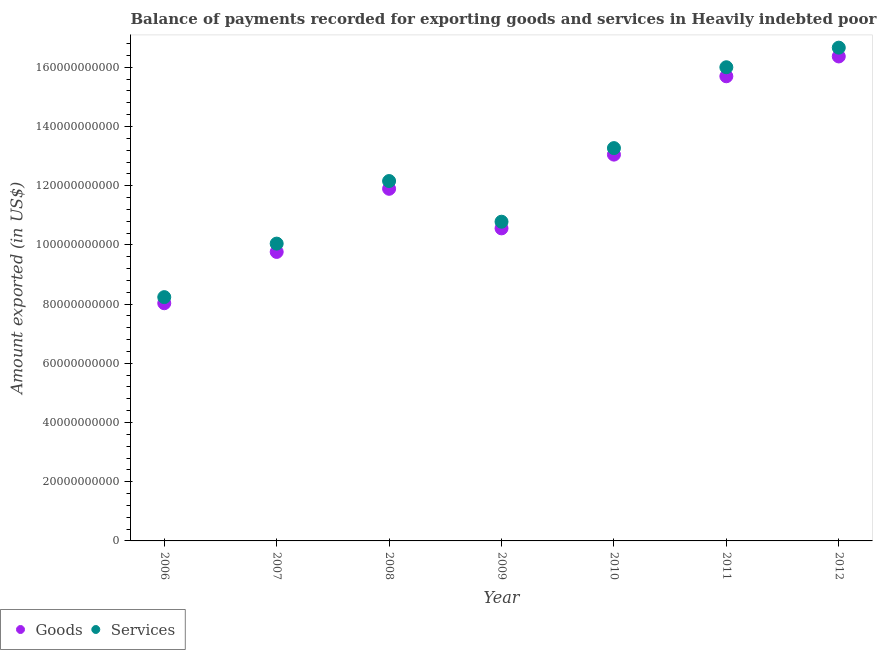How many different coloured dotlines are there?
Make the answer very short. 2. What is the amount of services exported in 2006?
Your answer should be very brief. 8.24e+1. Across all years, what is the maximum amount of goods exported?
Give a very brief answer. 1.64e+11. Across all years, what is the minimum amount of goods exported?
Offer a terse response. 8.03e+1. In which year was the amount of goods exported minimum?
Offer a terse response. 2006. What is the total amount of goods exported in the graph?
Provide a short and direct response. 8.54e+11. What is the difference between the amount of services exported in 2010 and that in 2011?
Keep it short and to the point. -2.73e+1. What is the difference between the amount of goods exported in 2007 and the amount of services exported in 2010?
Ensure brevity in your answer.  -3.51e+1. What is the average amount of services exported per year?
Give a very brief answer. 1.25e+11. In the year 2008, what is the difference between the amount of services exported and amount of goods exported?
Make the answer very short. 2.62e+09. What is the ratio of the amount of goods exported in 2011 to that in 2012?
Give a very brief answer. 0.96. Is the difference between the amount of services exported in 2010 and 2011 greater than the difference between the amount of goods exported in 2010 and 2011?
Offer a very short reply. No. What is the difference between the highest and the second highest amount of services exported?
Your answer should be compact. 6.62e+09. What is the difference between the highest and the lowest amount of goods exported?
Provide a short and direct response. 8.34e+1. Is the amount of goods exported strictly greater than the amount of services exported over the years?
Provide a short and direct response. No. How many dotlines are there?
Provide a succinct answer. 2. How many years are there in the graph?
Offer a terse response. 7. Does the graph contain any zero values?
Keep it short and to the point. No. Does the graph contain grids?
Offer a terse response. No. What is the title of the graph?
Provide a short and direct response. Balance of payments recorded for exporting goods and services in Heavily indebted poor countries. Does "Male entrants" appear as one of the legend labels in the graph?
Make the answer very short. No. What is the label or title of the X-axis?
Your answer should be compact. Year. What is the label or title of the Y-axis?
Your response must be concise. Amount exported (in US$). What is the Amount exported (in US$) in Goods in 2006?
Provide a short and direct response. 8.03e+1. What is the Amount exported (in US$) of Services in 2006?
Make the answer very short. 8.24e+1. What is the Amount exported (in US$) in Goods in 2007?
Your response must be concise. 9.76e+1. What is the Amount exported (in US$) in Services in 2007?
Make the answer very short. 1.00e+11. What is the Amount exported (in US$) in Goods in 2008?
Provide a succinct answer. 1.19e+11. What is the Amount exported (in US$) in Services in 2008?
Ensure brevity in your answer.  1.22e+11. What is the Amount exported (in US$) in Goods in 2009?
Your answer should be compact. 1.06e+11. What is the Amount exported (in US$) in Services in 2009?
Make the answer very short. 1.08e+11. What is the Amount exported (in US$) of Goods in 2010?
Provide a succinct answer. 1.30e+11. What is the Amount exported (in US$) in Services in 2010?
Your answer should be very brief. 1.33e+11. What is the Amount exported (in US$) in Goods in 2011?
Your answer should be very brief. 1.57e+11. What is the Amount exported (in US$) in Services in 2011?
Offer a terse response. 1.60e+11. What is the Amount exported (in US$) of Goods in 2012?
Offer a very short reply. 1.64e+11. What is the Amount exported (in US$) of Services in 2012?
Ensure brevity in your answer.  1.67e+11. Across all years, what is the maximum Amount exported (in US$) in Goods?
Keep it short and to the point. 1.64e+11. Across all years, what is the maximum Amount exported (in US$) in Services?
Provide a short and direct response. 1.67e+11. Across all years, what is the minimum Amount exported (in US$) in Goods?
Offer a very short reply. 8.03e+1. Across all years, what is the minimum Amount exported (in US$) of Services?
Give a very brief answer. 8.24e+1. What is the total Amount exported (in US$) of Goods in the graph?
Provide a short and direct response. 8.54e+11. What is the total Amount exported (in US$) in Services in the graph?
Your answer should be compact. 8.72e+11. What is the difference between the Amount exported (in US$) in Goods in 2006 and that in 2007?
Offer a terse response. -1.73e+1. What is the difference between the Amount exported (in US$) in Services in 2006 and that in 2007?
Your answer should be compact. -1.81e+1. What is the difference between the Amount exported (in US$) of Goods in 2006 and that in 2008?
Give a very brief answer. -3.87e+1. What is the difference between the Amount exported (in US$) in Services in 2006 and that in 2008?
Ensure brevity in your answer.  -3.92e+1. What is the difference between the Amount exported (in US$) in Goods in 2006 and that in 2009?
Give a very brief answer. -2.53e+1. What is the difference between the Amount exported (in US$) of Services in 2006 and that in 2009?
Ensure brevity in your answer.  -2.55e+1. What is the difference between the Amount exported (in US$) in Goods in 2006 and that in 2010?
Your answer should be very brief. -5.02e+1. What is the difference between the Amount exported (in US$) in Services in 2006 and that in 2010?
Give a very brief answer. -5.03e+1. What is the difference between the Amount exported (in US$) in Goods in 2006 and that in 2011?
Provide a succinct answer. -7.67e+1. What is the difference between the Amount exported (in US$) of Services in 2006 and that in 2011?
Keep it short and to the point. -7.77e+1. What is the difference between the Amount exported (in US$) of Goods in 2006 and that in 2012?
Offer a terse response. -8.34e+1. What is the difference between the Amount exported (in US$) in Services in 2006 and that in 2012?
Give a very brief answer. -8.43e+1. What is the difference between the Amount exported (in US$) in Goods in 2007 and that in 2008?
Provide a succinct answer. -2.13e+1. What is the difference between the Amount exported (in US$) of Services in 2007 and that in 2008?
Your answer should be very brief. -2.11e+1. What is the difference between the Amount exported (in US$) of Goods in 2007 and that in 2009?
Your answer should be very brief. -7.96e+09. What is the difference between the Amount exported (in US$) of Services in 2007 and that in 2009?
Offer a very short reply. -7.40e+09. What is the difference between the Amount exported (in US$) of Goods in 2007 and that in 2010?
Provide a succinct answer. -3.29e+1. What is the difference between the Amount exported (in US$) of Services in 2007 and that in 2010?
Offer a terse response. -3.23e+1. What is the difference between the Amount exported (in US$) in Goods in 2007 and that in 2011?
Provide a short and direct response. -5.93e+1. What is the difference between the Amount exported (in US$) of Services in 2007 and that in 2011?
Provide a short and direct response. -5.96e+1. What is the difference between the Amount exported (in US$) in Goods in 2007 and that in 2012?
Your response must be concise. -6.60e+1. What is the difference between the Amount exported (in US$) of Services in 2007 and that in 2012?
Offer a very short reply. -6.62e+1. What is the difference between the Amount exported (in US$) in Goods in 2008 and that in 2009?
Offer a very short reply. 1.34e+1. What is the difference between the Amount exported (in US$) of Services in 2008 and that in 2009?
Offer a terse response. 1.37e+1. What is the difference between the Amount exported (in US$) in Goods in 2008 and that in 2010?
Give a very brief answer. -1.15e+1. What is the difference between the Amount exported (in US$) in Services in 2008 and that in 2010?
Your response must be concise. -1.11e+1. What is the difference between the Amount exported (in US$) in Goods in 2008 and that in 2011?
Make the answer very short. -3.80e+1. What is the difference between the Amount exported (in US$) of Services in 2008 and that in 2011?
Your response must be concise. -3.84e+1. What is the difference between the Amount exported (in US$) in Goods in 2008 and that in 2012?
Give a very brief answer. -4.47e+1. What is the difference between the Amount exported (in US$) of Services in 2008 and that in 2012?
Provide a short and direct response. -4.51e+1. What is the difference between the Amount exported (in US$) of Goods in 2009 and that in 2010?
Keep it short and to the point. -2.49e+1. What is the difference between the Amount exported (in US$) of Services in 2009 and that in 2010?
Offer a very short reply. -2.49e+1. What is the difference between the Amount exported (in US$) of Goods in 2009 and that in 2011?
Keep it short and to the point. -5.14e+1. What is the difference between the Amount exported (in US$) in Services in 2009 and that in 2011?
Ensure brevity in your answer.  -5.22e+1. What is the difference between the Amount exported (in US$) of Goods in 2009 and that in 2012?
Make the answer very short. -5.81e+1. What is the difference between the Amount exported (in US$) of Services in 2009 and that in 2012?
Give a very brief answer. -5.88e+1. What is the difference between the Amount exported (in US$) of Goods in 2010 and that in 2011?
Make the answer very short. -2.65e+1. What is the difference between the Amount exported (in US$) of Services in 2010 and that in 2011?
Keep it short and to the point. -2.73e+1. What is the difference between the Amount exported (in US$) in Goods in 2010 and that in 2012?
Your answer should be very brief. -3.32e+1. What is the difference between the Amount exported (in US$) of Services in 2010 and that in 2012?
Provide a succinct answer. -3.39e+1. What is the difference between the Amount exported (in US$) of Goods in 2011 and that in 2012?
Your answer should be compact. -6.70e+09. What is the difference between the Amount exported (in US$) of Services in 2011 and that in 2012?
Give a very brief answer. -6.62e+09. What is the difference between the Amount exported (in US$) of Goods in 2006 and the Amount exported (in US$) of Services in 2007?
Keep it short and to the point. -2.01e+1. What is the difference between the Amount exported (in US$) in Goods in 2006 and the Amount exported (in US$) in Services in 2008?
Keep it short and to the point. -4.13e+1. What is the difference between the Amount exported (in US$) of Goods in 2006 and the Amount exported (in US$) of Services in 2009?
Ensure brevity in your answer.  -2.75e+1. What is the difference between the Amount exported (in US$) in Goods in 2006 and the Amount exported (in US$) in Services in 2010?
Keep it short and to the point. -5.24e+1. What is the difference between the Amount exported (in US$) of Goods in 2006 and the Amount exported (in US$) of Services in 2011?
Give a very brief answer. -7.97e+1. What is the difference between the Amount exported (in US$) in Goods in 2006 and the Amount exported (in US$) in Services in 2012?
Make the answer very short. -8.63e+1. What is the difference between the Amount exported (in US$) in Goods in 2007 and the Amount exported (in US$) in Services in 2008?
Make the answer very short. -2.39e+1. What is the difference between the Amount exported (in US$) in Goods in 2007 and the Amount exported (in US$) in Services in 2009?
Make the answer very short. -1.02e+1. What is the difference between the Amount exported (in US$) of Goods in 2007 and the Amount exported (in US$) of Services in 2010?
Your response must be concise. -3.51e+1. What is the difference between the Amount exported (in US$) in Goods in 2007 and the Amount exported (in US$) in Services in 2011?
Your answer should be compact. -6.24e+1. What is the difference between the Amount exported (in US$) of Goods in 2007 and the Amount exported (in US$) of Services in 2012?
Ensure brevity in your answer.  -6.90e+1. What is the difference between the Amount exported (in US$) in Goods in 2008 and the Amount exported (in US$) in Services in 2009?
Provide a succinct answer. 1.11e+1. What is the difference between the Amount exported (in US$) in Goods in 2008 and the Amount exported (in US$) in Services in 2010?
Make the answer very short. -1.37e+1. What is the difference between the Amount exported (in US$) of Goods in 2008 and the Amount exported (in US$) of Services in 2011?
Provide a short and direct response. -4.11e+1. What is the difference between the Amount exported (in US$) of Goods in 2008 and the Amount exported (in US$) of Services in 2012?
Give a very brief answer. -4.77e+1. What is the difference between the Amount exported (in US$) in Goods in 2009 and the Amount exported (in US$) in Services in 2010?
Your answer should be very brief. -2.71e+1. What is the difference between the Amount exported (in US$) of Goods in 2009 and the Amount exported (in US$) of Services in 2011?
Keep it short and to the point. -5.44e+1. What is the difference between the Amount exported (in US$) in Goods in 2009 and the Amount exported (in US$) in Services in 2012?
Provide a short and direct response. -6.10e+1. What is the difference between the Amount exported (in US$) in Goods in 2010 and the Amount exported (in US$) in Services in 2011?
Your answer should be compact. -2.95e+1. What is the difference between the Amount exported (in US$) of Goods in 2010 and the Amount exported (in US$) of Services in 2012?
Offer a terse response. -3.61e+1. What is the difference between the Amount exported (in US$) in Goods in 2011 and the Amount exported (in US$) in Services in 2012?
Offer a very short reply. -9.67e+09. What is the average Amount exported (in US$) in Goods per year?
Keep it short and to the point. 1.22e+11. What is the average Amount exported (in US$) in Services per year?
Give a very brief answer. 1.25e+11. In the year 2006, what is the difference between the Amount exported (in US$) of Goods and Amount exported (in US$) of Services?
Offer a very short reply. -2.06e+09. In the year 2007, what is the difference between the Amount exported (in US$) of Goods and Amount exported (in US$) of Services?
Offer a terse response. -2.81e+09. In the year 2008, what is the difference between the Amount exported (in US$) of Goods and Amount exported (in US$) of Services?
Offer a terse response. -2.62e+09. In the year 2009, what is the difference between the Amount exported (in US$) in Goods and Amount exported (in US$) in Services?
Offer a very short reply. -2.25e+09. In the year 2010, what is the difference between the Amount exported (in US$) in Goods and Amount exported (in US$) in Services?
Provide a short and direct response. -2.20e+09. In the year 2011, what is the difference between the Amount exported (in US$) in Goods and Amount exported (in US$) in Services?
Your answer should be compact. -3.05e+09. In the year 2012, what is the difference between the Amount exported (in US$) of Goods and Amount exported (in US$) of Services?
Your answer should be very brief. -2.97e+09. What is the ratio of the Amount exported (in US$) in Goods in 2006 to that in 2007?
Make the answer very short. 0.82. What is the ratio of the Amount exported (in US$) in Services in 2006 to that in 2007?
Provide a short and direct response. 0.82. What is the ratio of the Amount exported (in US$) in Goods in 2006 to that in 2008?
Your answer should be very brief. 0.68. What is the ratio of the Amount exported (in US$) in Services in 2006 to that in 2008?
Offer a very short reply. 0.68. What is the ratio of the Amount exported (in US$) in Goods in 2006 to that in 2009?
Make the answer very short. 0.76. What is the ratio of the Amount exported (in US$) in Services in 2006 to that in 2009?
Ensure brevity in your answer.  0.76. What is the ratio of the Amount exported (in US$) of Goods in 2006 to that in 2010?
Keep it short and to the point. 0.62. What is the ratio of the Amount exported (in US$) of Services in 2006 to that in 2010?
Offer a terse response. 0.62. What is the ratio of the Amount exported (in US$) in Goods in 2006 to that in 2011?
Ensure brevity in your answer.  0.51. What is the ratio of the Amount exported (in US$) in Services in 2006 to that in 2011?
Make the answer very short. 0.51. What is the ratio of the Amount exported (in US$) in Goods in 2006 to that in 2012?
Give a very brief answer. 0.49. What is the ratio of the Amount exported (in US$) in Services in 2006 to that in 2012?
Your answer should be very brief. 0.49. What is the ratio of the Amount exported (in US$) of Goods in 2007 to that in 2008?
Your answer should be compact. 0.82. What is the ratio of the Amount exported (in US$) of Services in 2007 to that in 2008?
Offer a terse response. 0.83. What is the ratio of the Amount exported (in US$) in Goods in 2007 to that in 2009?
Provide a short and direct response. 0.92. What is the ratio of the Amount exported (in US$) in Services in 2007 to that in 2009?
Offer a very short reply. 0.93. What is the ratio of the Amount exported (in US$) of Goods in 2007 to that in 2010?
Ensure brevity in your answer.  0.75. What is the ratio of the Amount exported (in US$) in Services in 2007 to that in 2010?
Your answer should be very brief. 0.76. What is the ratio of the Amount exported (in US$) of Goods in 2007 to that in 2011?
Your answer should be compact. 0.62. What is the ratio of the Amount exported (in US$) in Services in 2007 to that in 2011?
Make the answer very short. 0.63. What is the ratio of the Amount exported (in US$) in Goods in 2007 to that in 2012?
Your response must be concise. 0.6. What is the ratio of the Amount exported (in US$) of Services in 2007 to that in 2012?
Offer a terse response. 0.6. What is the ratio of the Amount exported (in US$) in Goods in 2008 to that in 2009?
Give a very brief answer. 1.13. What is the ratio of the Amount exported (in US$) in Services in 2008 to that in 2009?
Ensure brevity in your answer.  1.13. What is the ratio of the Amount exported (in US$) in Goods in 2008 to that in 2010?
Provide a short and direct response. 0.91. What is the ratio of the Amount exported (in US$) in Services in 2008 to that in 2010?
Your response must be concise. 0.92. What is the ratio of the Amount exported (in US$) in Goods in 2008 to that in 2011?
Provide a short and direct response. 0.76. What is the ratio of the Amount exported (in US$) of Services in 2008 to that in 2011?
Offer a very short reply. 0.76. What is the ratio of the Amount exported (in US$) of Goods in 2008 to that in 2012?
Make the answer very short. 0.73. What is the ratio of the Amount exported (in US$) in Services in 2008 to that in 2012?
Provide a short and direct response. 0.73. What is the ratio of the Amount exported (in US$) in Goods in 2009 to that in 2010?
Provide a succinct answer. 0.81. What is the ratio of the Amount exported (in US$) of Services in 2009 to that in 2010?
Your response must be concise. 0.81. What is the ratio of the Amount exported (in US$) in Goods in 2009 to that in 2011?
Offer a very short reply. 0.67. What is the ratio of the Amount exported (in US$) of Services in 2009 to that in 2011?
Offer a terse response. 0.67. What is the ratio of the Amount exported (in US$) of Goods in 2009 to that in 2012?
Provide a succinct answer. 0.65. What is the ratio of the Amount exported (in US$) in Services in 2009 to that in 2012?
Keep it short and to the point. 0.65. What is the ratio of the Amount exported (in US$) of Goods in 2010 to that in 2011?
Keep it short and to the point. 0.83. What is the ratio of the Amount exported (in US$) of Services in 2010 to that in 2011?
Provide a short and direct response. 0.83. What is the ratio of the Amount exported (in US$) of Goods in 2010 to that in 2012?
Provide a succinct answer. 0.8. What is the ratio of the Amount exported (in US$) of Services in 2010 to that in 2012?
Provide a short and direct response. 0.8. What is the ratio of the Amount exported (in US$) of Goods in 2011 to that in 2012?
Your answer should be compact. 0.96. What is the ratio of the Amount exported (in US$) of Services in 2011 to that in 2012?
Give a very brief answer. 0.96. What is the difference between the highest and the second highest Amount exported (in US$) in Goods?
Keep it short and to the point. 6.70e+09. What is the difference between the highest and the second highest Amount exported (in US$) in Services?
Ensure brevity in your answer.  6.62e+09. What is the difference between the highest and the lowest Amount exported (in US$) in Goods?
Your response must be concise. 8.34e+1. What is the difference between the highest and the lowest Amount exported (in US$) in Services?
Make the answer very short. 8.43e+1. 